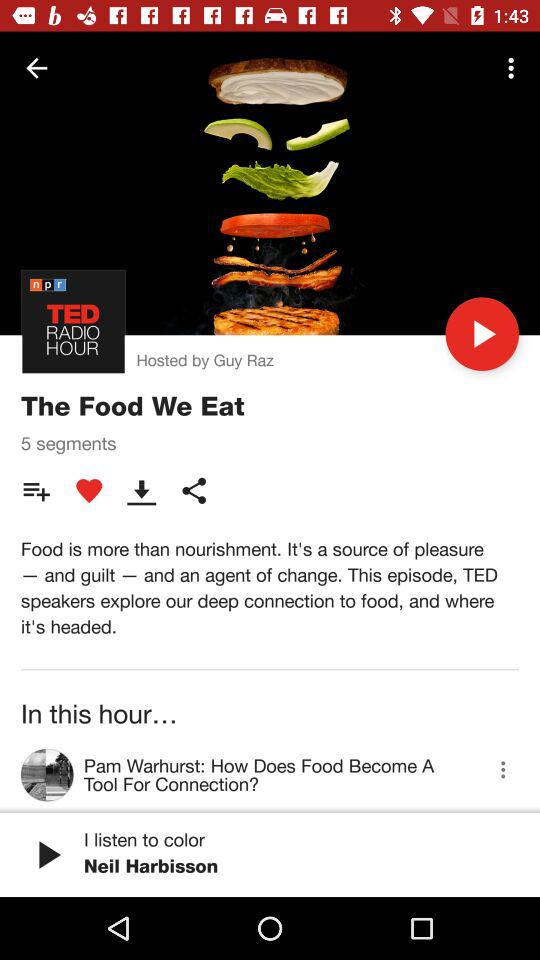Which TED talk was last played? The last played TED talk was "I listen to color". 